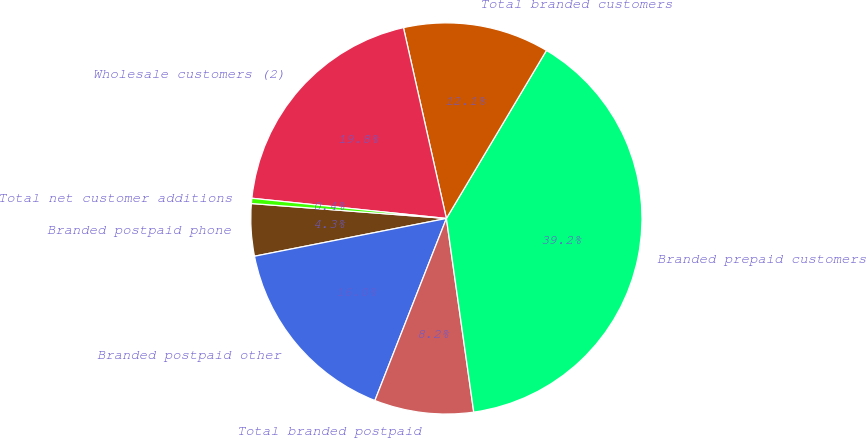<chart> <loc_0><loc_0><loc_500><loc_500><pie_chart><fcel>Branded postpaid phone<fcel>Branded postpaid other<fcel>Total branded postpaid<fcel>Branded prepaid customers<fcel>Total branded customers<fcel>Wholesale customers (2)<fcel>Total net customer additions<nl><fcel>4.31%<fcel>15.95%<fcel>8.19%<fcel>39.22%<fcel>12.07%<fcel>19.83%<fcel>0.43%<nl></chart> 